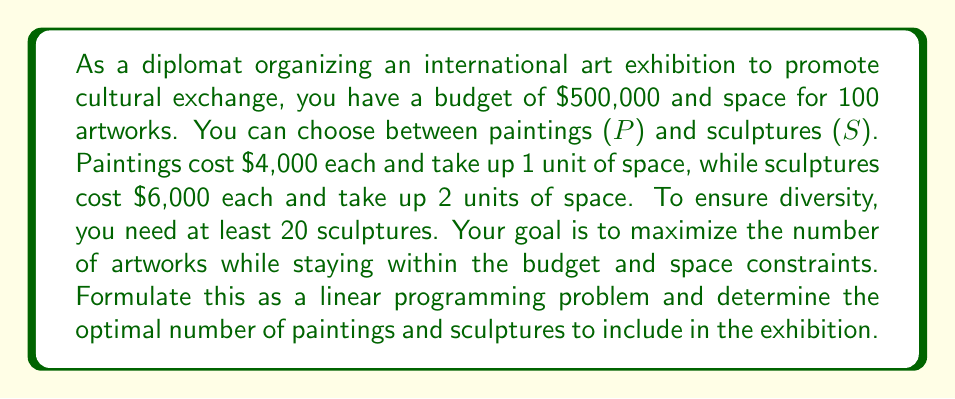Help me with this question. Let's approach this step-by-step:

1) Define variables:
   $P$ = number of paintings
   $S$ = number of sculptures

2) Objective function:
   Maximize the total number of artworks: $\max(P + S)$

3) Constraints:
   a) Budget constraint: $4000P + 6000S \leq 500000$
   b) Space constraint: $P + 2S \leq 100$
   c) Minimum sculptures: $S \geq 20$
   d) Non-negativity: $P \geq 0, S \geq 0$

4) Simplify the budget constraint:
   $4P + 6S \leq 500$

5) We can solve this using the graphical method. Plot the constraints:
   [asy]
   import graph;
   size(200);
   xaxis("P", 0, 125);
   yaxis("S", 0, 60);
   draw((0,20)--(125,20), green);
   draw((0,50)--(125,0), red);
   draw((0,50)--(100,0), blue);
   label("Budget", (60,40), E, red);
   label("Space", (80,25), SE, blue);
   label("Min S", (60,20), N, green);
   fill((20,20)--(83.33,20)--(50,25)--(20,40)--cycle, gray(0.9));
   dot((50,25));
   label("(50,25)", (50,25), NE);
   [/asy]

6) The feasible region is the shaded area. The optimal solution will be at one of the corner points.

7) Corner points:
   (20, 40): P + S = 60
   (83.33, 20): P + S = 103.33
   (50, 25): P + S = 75

8) The optimal solution is at (83.33, 20), but we need integer values.

9) Rounding down to maintain feasibility:
   P = 83, S = 20
   Total artworks: 83 + 20 = 103

10) Verify constraints:
    Budget: $4(83) + 6(20) = 452 \leq 500$
    Space: $83 + 2(20) = 123 \leq 100$ (Not satisfied)

11) Adjust to satisfy space constraint:
    P = 60, S = 20
    Total artworks: 60 + 20 = 80

12) Final verification:
    Budget: $4(60) + 6(20) = 360 \leq 500$
    Space: $60 + 2(20) = 100 \leq 100$
    Minimum sculptures: $20 \geq 20$
Answer: The optimal solution is to include 60 paintings and 20 sculptures, for a total of 80 artworks. 